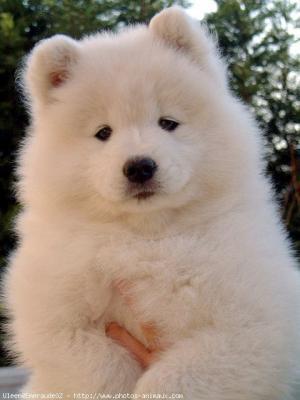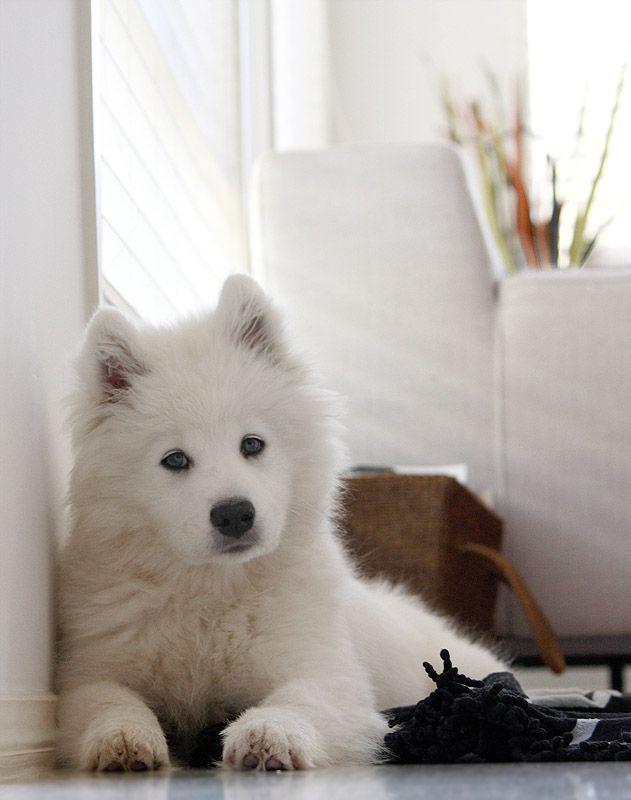The first image is the image on the left, the second image is the image on the right. For the images displayed, is the sentence "An image shows a white dog posed indoors in a white room." factually correct? Answer yes or no. Yes. The first image is the image on the left, the second image is the image on the right. Evaluate the accuracy of this statement regarding the images: "At least one of the dogs is standing outside.". Is it true? Answer yes or no. No. 